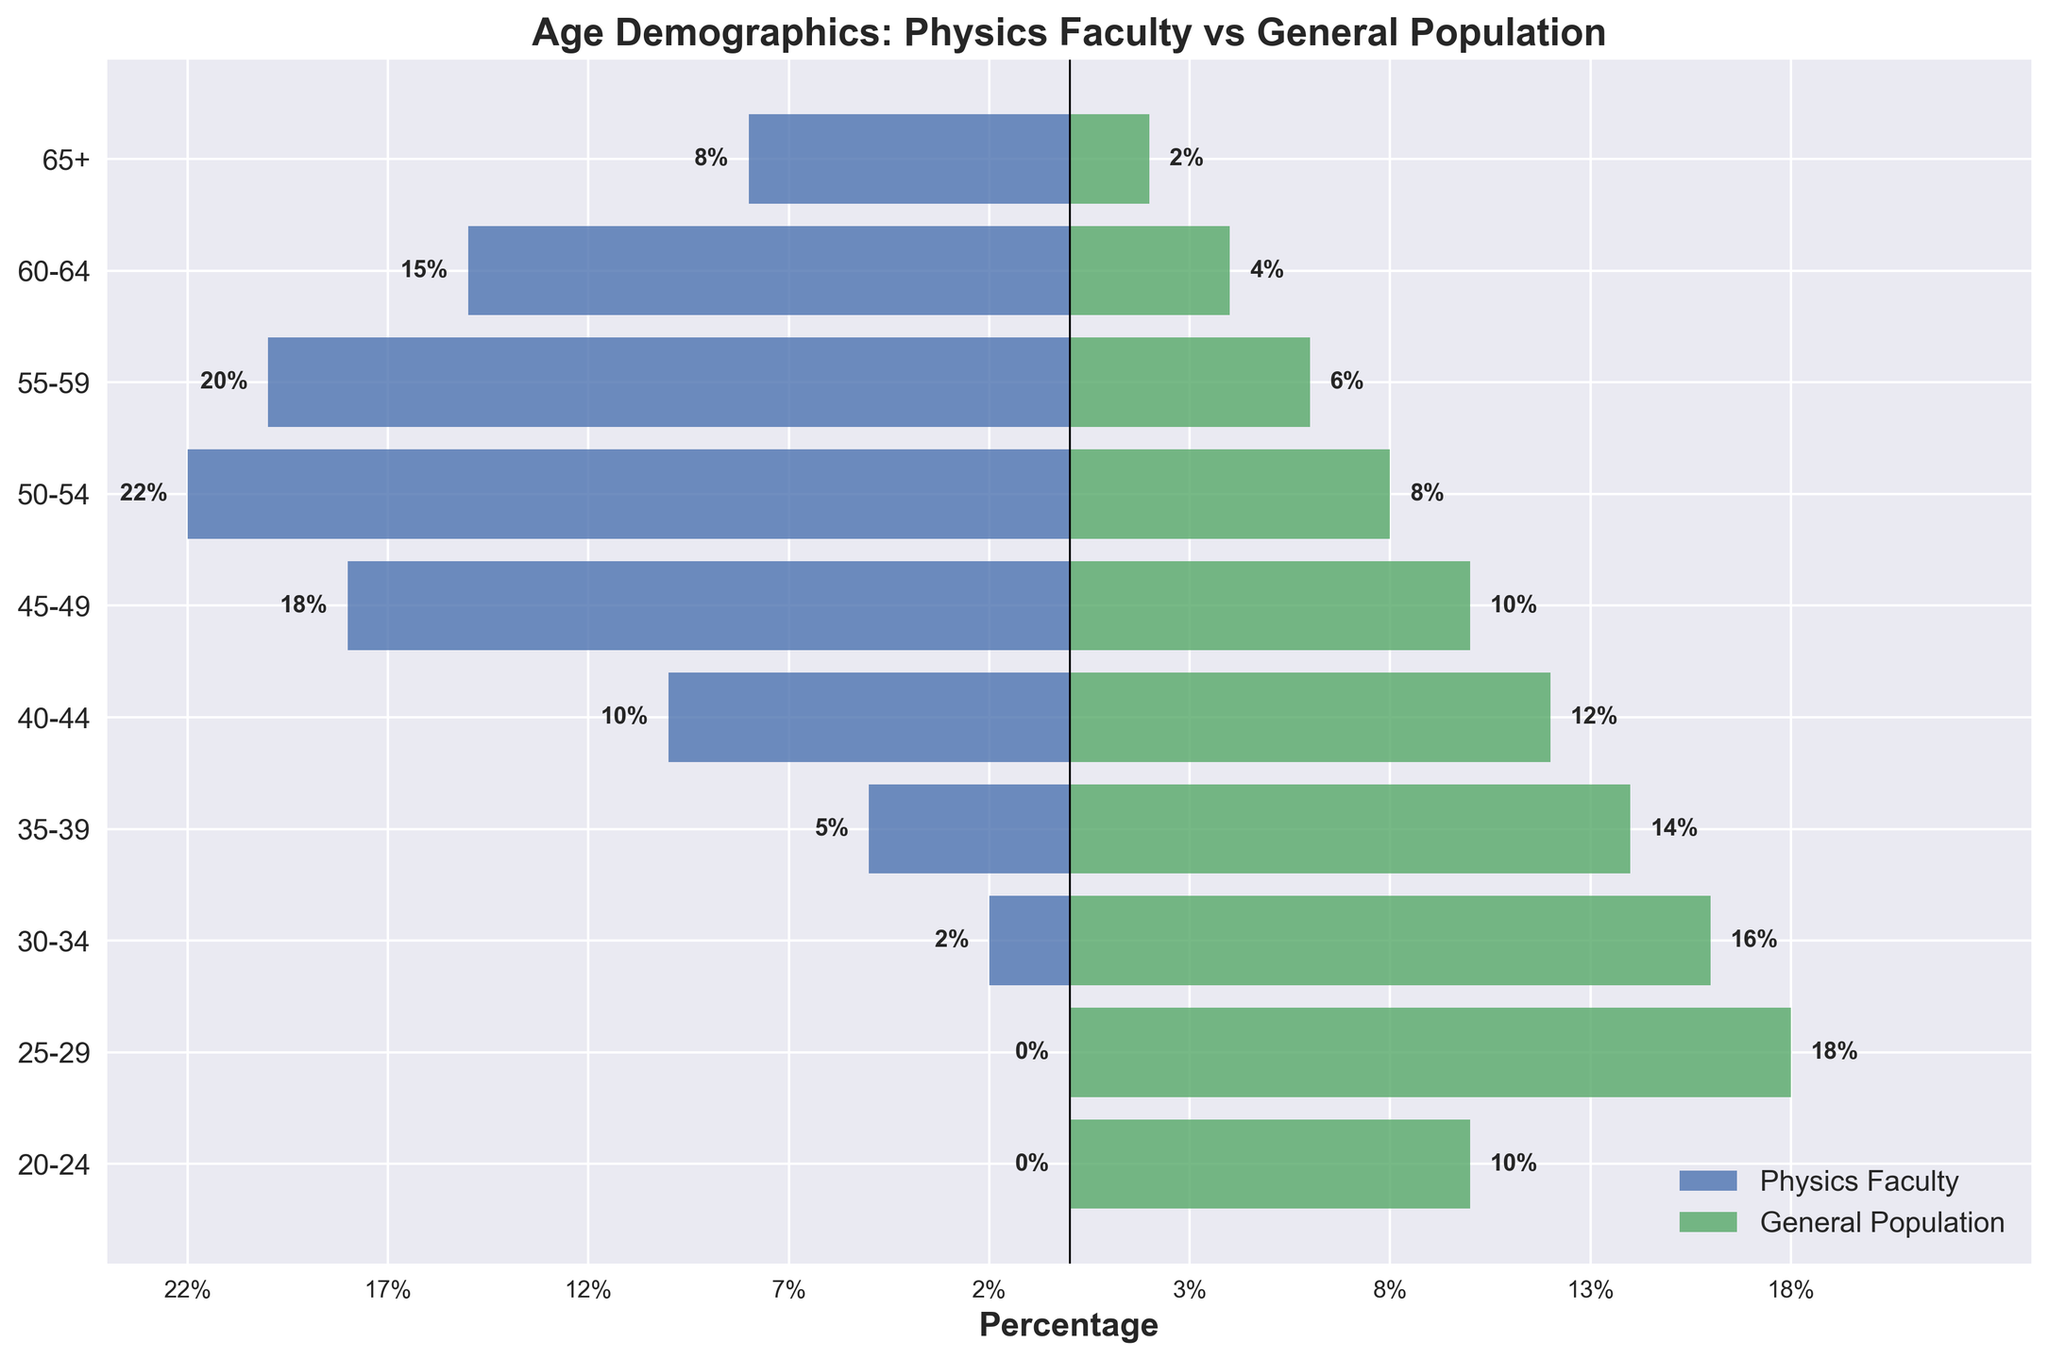What is the title of the plot? The title is located at the top of the plot. It is set to give viewers an understanding of what the data is about.
Answer: Age Demographics: Physics Faculty vs General Population Which group has the highest percentage of people aged 50-54? By examining the horizontal bars for the age group 50-54, we can compare the lengths. The Physics Faculty has a longer bar in this age group compared to the General Population.
Answer: Physics Faculty How many age groups have a higher percentage in the General Population compared to the Physics Faculty? By comparing the lengths of each horizontal bar for both groups, we see that there are more age groups where the General Population has a higher percentage. Specifically, these age groups are 40-44, 35-39, 30-34, 25-29, and 20-24.
Answer: 5 Which age group has the biggest difference in percentage between the Physics Faculty and the General Population? Look at the bars for each age group to find the largest gap. The age group 25-29 has a 0% in Physics Faculty versus 18% in the General Population, making it the largest difference.
Answer: 25-29 Is there any age group where the percentages are the same between both groups? By visually checking the bar lengths for each age group, we see that there are no bars that have equal lengths, indicating no age group has the same percentage.
Answer: No What is the total percentage of Physics Faculty aged 55 and above? Sum the percentages of age groups 55-59, 60-64, and 65+. These are 20% + 15% + 8%, respectively. So, 20% + 15% + 8% = 43%.
Answer: 43% Do the General Population percentages sum up to 100% across all age groups? Add the percentages given for the General Population across all age groups: 2% + 4% + 6% + 8% + 10% + 12% + 14% + 16% + 18% + 10%. Summing these gives us 100%.
Answer: Yes In which age group is the percentage decrease the most dramatic from General Population to Physics Faculty? Calculate the percentage differences for each age group. The age group 25-29 sees a drop from 18% in the General Population to 0% in Physics Faculty, making it the most dramatic decrease.
Answer: 25-29 In how many age groups is the Physics Faculty percentage higher than the General Population percentage? Count the age groups where the Physics Faculty bar is longer than the General Population bar. These age groups are 65+, 60-64, 55-59, 50-54, and 45-49.
Answer: 5 